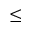<formula> <loc_0><loc_0><loc_500><loc_500>\leq</formula> 